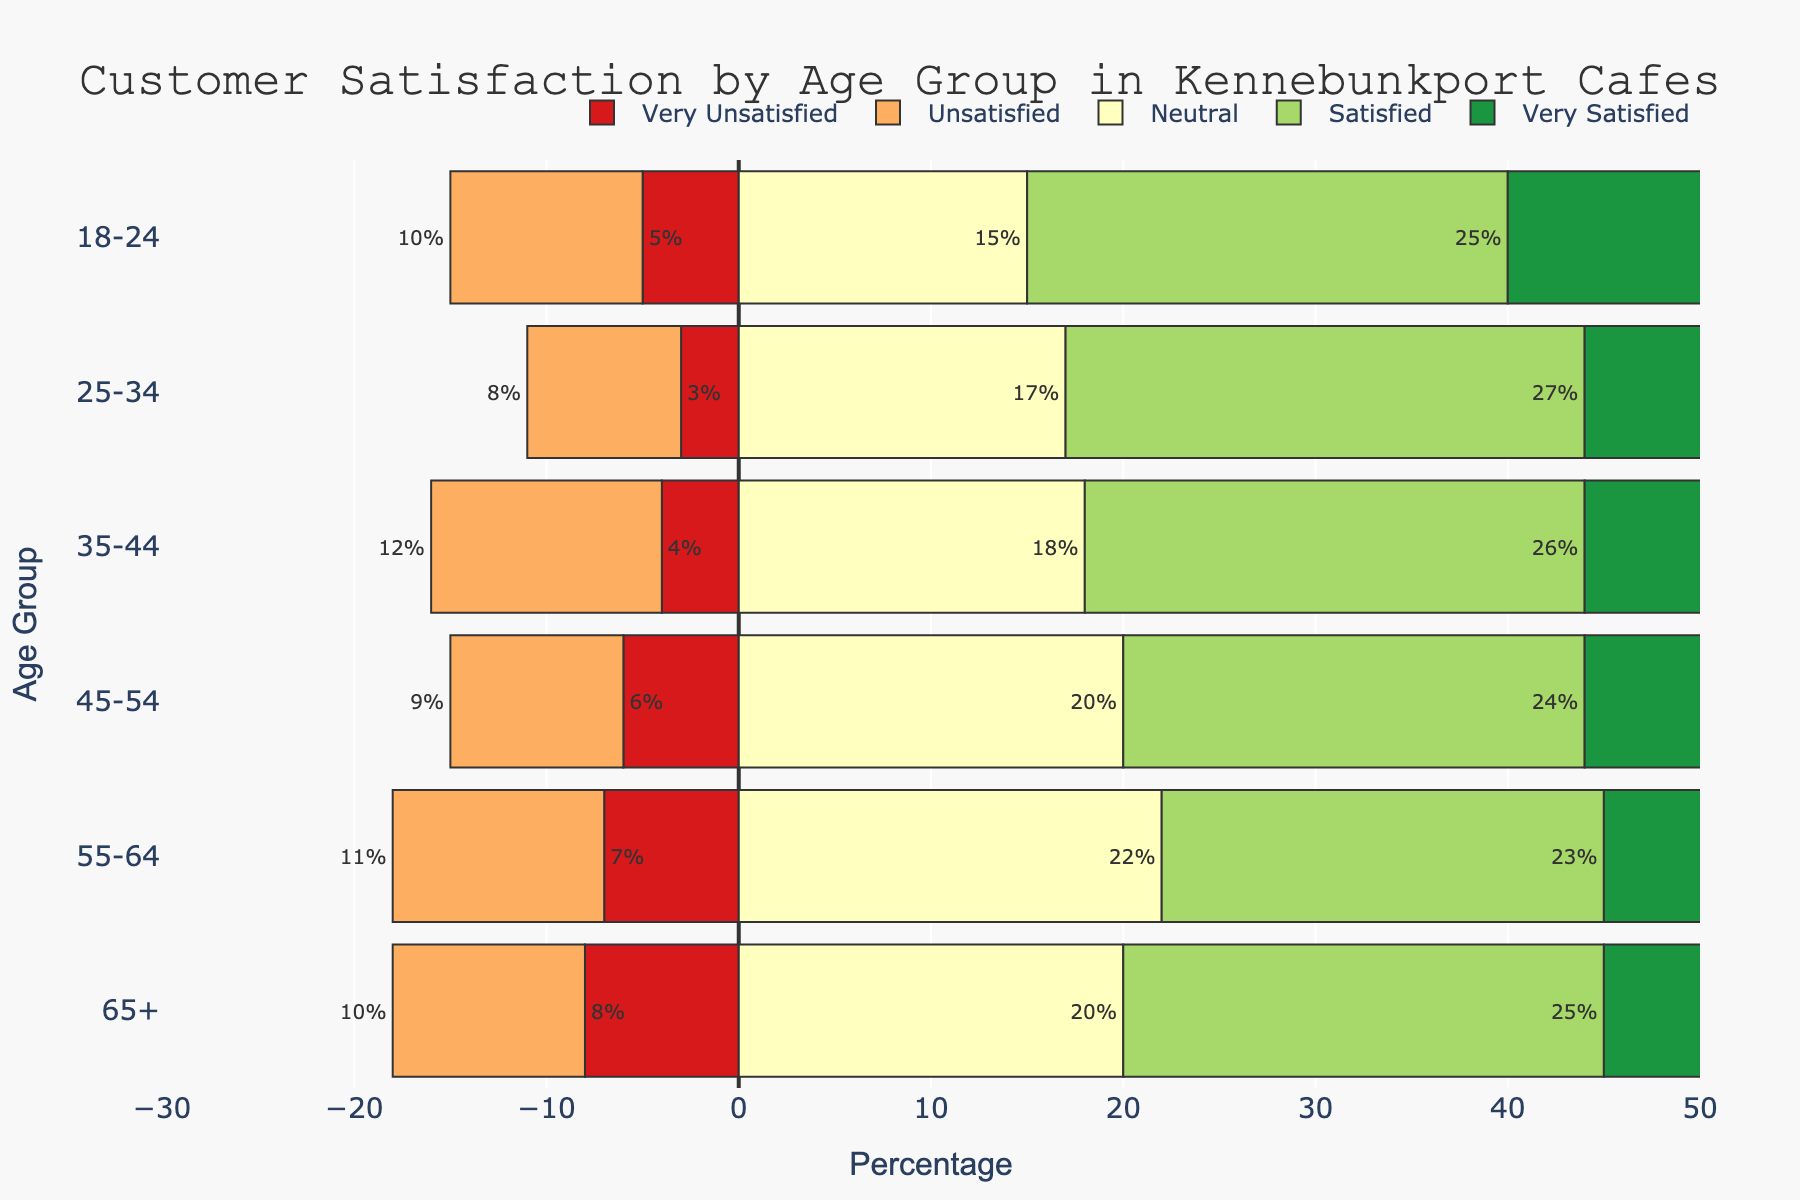What's the age group with the highest percentage of 'Very Satisfied' customers? To find the answer, look at the bars representing 'Very Satisfied' for each age group and identify the longest bar. 'Very Satisfied' is shown in green color. The 18-24 and 25-34 age groups both have the highest bar for 'Very Satisfied' at 45%.
Answer: 18-24 and 25-34 Which age group has the most 'Very Unsatisfied' customers? To answer this, check the bars for 'Very Unsatisfied' customers, represented in red color. The longest bar for 'Very Unsatisfied' is in the 65+ age group at 8%.
Answer: 65+ What is the combined percentage of 'Neutral' and 'Satisfied' customers for the 35-44 age group? First, find the percentage of 'Neutral' (18%) and 'Satisfied' (26%) for the 35-44 age group, then add these two values together: 18% + 26% = 44%.
Answer: 44% Which age group has the least 'Unsatisfied' customers? Look for the shortest bar in the 'Unsatisfied' category, represented in orange. The 25-34 age group has 8%, which is the smallest percentage.
Answer: 25-34 How does the percentage of 'Neutral' customers in the 55-64 age group compare to those in the 18-24 age group? The 'Neutral' category is shown in yellow. The 55-64 age group has 22% and the 18-24 age group has 15%. Comparing them, 22% is greater than 15%.
Answer: 22% > 15% What is the difference between the percentages of 'Satisfied' customers in the 45-54 age group and the 25-34 age group? The 'Satisfied' category is shown in light green. The 45-54 age group has 24% and the 25-34 age group has 27%. To find the difference, subtract the smaller value from the larger value: 27% - 24% = 3%.
Answer: 3% What percentage of customers in the 65+ age group are either 'Very Unsatisfied' or 'Satisfied'? Look at the bars for 'Very Unsatisfied' (8%) and 'Satisfied' (25%) in the 65+ age group. Add these values together: 8% + 25% = 33%.
Answer: 33% Which two age groups have the same percentage of 'Very Satisfied' customers? Find the bars for 'Very Satisfied' (green) and identify any age groups with matching lengths. Both the 18-24 and 25-34 age groups have a percentage of 45%.
Answer: 18-24 and 25-34 In which age group is the percentage of 'Unsatisfied' customers closest to the percentage of 'Satisfied' customers? Compare 'Unsatisfied' and 'Satisfied' bars for each age group. The 65+ age group has 'Unsatisfied' at 10% and 'Satisfied' at 25%, the closest in relative comparison to other age groups.
Answer: 65+ 